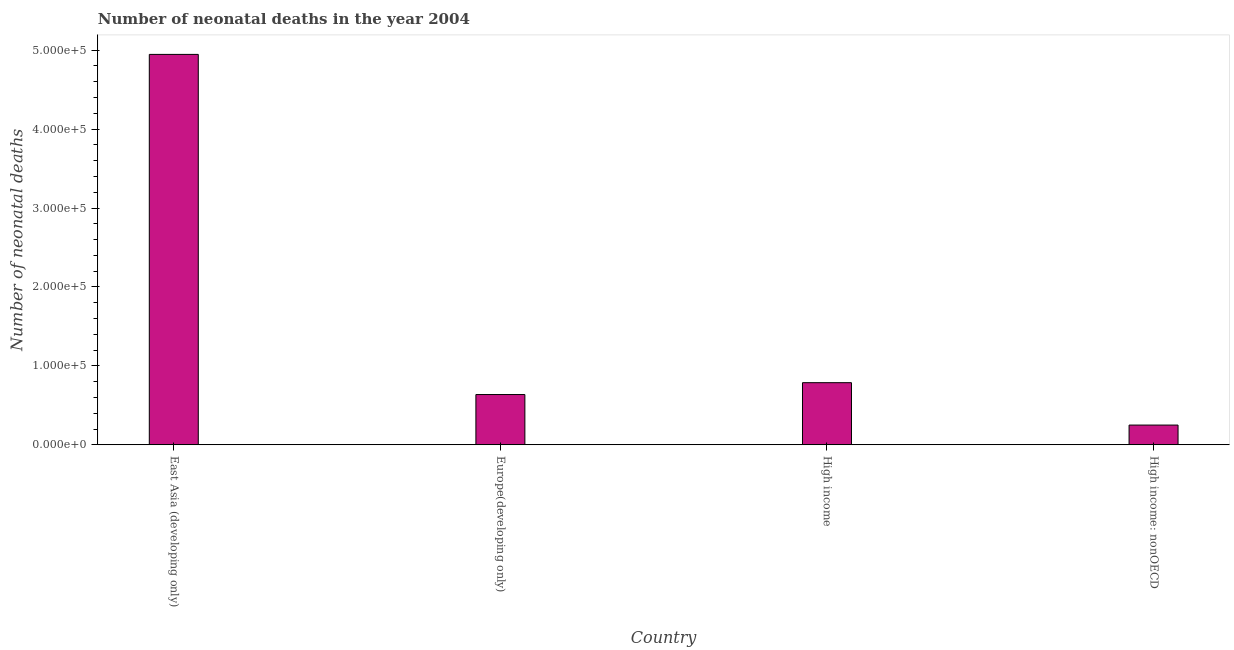Does the graph contain any zero values?
Give a very brief answer. No. What is the title of the graph?
Provide a short and direct response. Number of neonatal deaths in the year 2004. What is the label or title of the Y-axis?
Your answer should be very brief. Number of neonatal deaths. What is the number of neonatal deaths in Europe(developing only)?
Keep it short and to the point. 6.37e+04. Across all countries, what is the maximum number of neonatal deaths?
Give a very brief answer. 4.95e+05. Across all countries, what is the minimum number of neonatal deaths?
Ensure brevity in your answer.  2.50e+04. In which country was the number of neonatal deaths maximum?
Offer a terse response. East Asia (developing only). In which country was the number of neonatal deaths minimum?
Your answer should be very brief. High income: nonOECD. What is the sum of the number of neonatal deaths?
Give a very brief answer. 6.62e+05. What is the difference between the number of neonatal deaths in East Asia (developing only) and High income?
Give a very brief answer. 4.16e+05. What is the average number of neonatal deaths per country?
Ensure brevity in your answer.  1.66e+05. What is the median number of neonatal deaths?
Your answer should be compact. 7.12e+04. In how many countries, is the number of neonatal deaths greater than 420000 ?
Give a very brief answer. 1. What is the ratio of the number of neonatal deaths in East Asia (developing only) to that in High income: nonOECD?
Make the answer very short. 19.79. Is the difference between the number of neonatal deaths in Europe(developing only) and High income: nonOECD greater than the difference between any two countries?
Your answer should be compact. No. What is the difference between the highest and the second highest number of neonatal deaths?
Ensure brevity in your answer.  4.16e+05. What is the difference between the highest and the lowest number of neonatal deaths?
Your answer should be very brief. 4.70e+05. In how many countries, is the number of neonatal deaths greater than the average number of neonatal deaths taken over all countries?
Offer a terse response. 1. Are all the bars in the graph horizontal?
Ensure brevity in your answer.  No. How many countries are there in the graph?
Give a very brief answer. 4. What is the Number of neonatal deaths in East Asia (developing only)?
Give a very brief answer. 4.95e+05. What is the Number of neonatal deaths in Europe(developing only)?
Provide a short and direct response. 6.37e+04. What is the Number of neonatal deaths of High income?
Keep it short and to the point. 7.87e+04. What is the Number of neonatal deaths of High income: nonOECD?
Your answer should be compact. 2.50e+04. What is the difference between the Number of neonatal deaths in East Asia (developing only) and Europe(developing only)?
Offer a terse response. 4.31e+05. What is the difference between the Number of neonatal deaths in East Asia (developing only) and High income?
Your response must be concise. 4.16e+05. What is the difference between the Number of neonatal deaths in East Asia (developing only) and High income: nonOECD?
Your response must be concise. 4.70e+05. What is the difference between the Number of neonatal deaths in Europe(developing only) and High income?
Provide a succinct answer. -1.50e+04. What is the difference between the Number of neonatal deaths in Europe(developing only) and High income: nonOECD?
Offer a very short reply. 3.87e+04. What is the difference between the Number of neonatal deaths in High income and High income: nonOECD?
Give a very brief answer. 5.37e+04. What is the ratio of the Number of neonatal deaths in East Asia (developing only) to that in Europe(developing only)?
Offer a very short reply. 7.77. What is the ratio of the Number of neonatal deaths in East Asia (developing only) to that in High income?
Your response must be concise. 6.29. What is the ratio of the Number of neonatal deaths in East Asia (developing only) to that in High income: nonOECD?
Offer a very short reply. 19.79. What is the ratio of the Number of neonatal deaths in Europe(developing only) to that in High income?
Ensure brevity in your answer.  0.81. What is the ratio of the Number of neonatal deaths in Europe(developing only) to that in High income: nonOECD?
Offer a very short reply. 2.55. What is the ratio of the Number of neonatal deaths in High income to that in High income: nonOECD?
Provide a short and direct response. 3.15. 